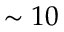Convert formula to latex. <formula><loc_0><loc_0><loc_500><loc_500>\sim 1 0</formula> 